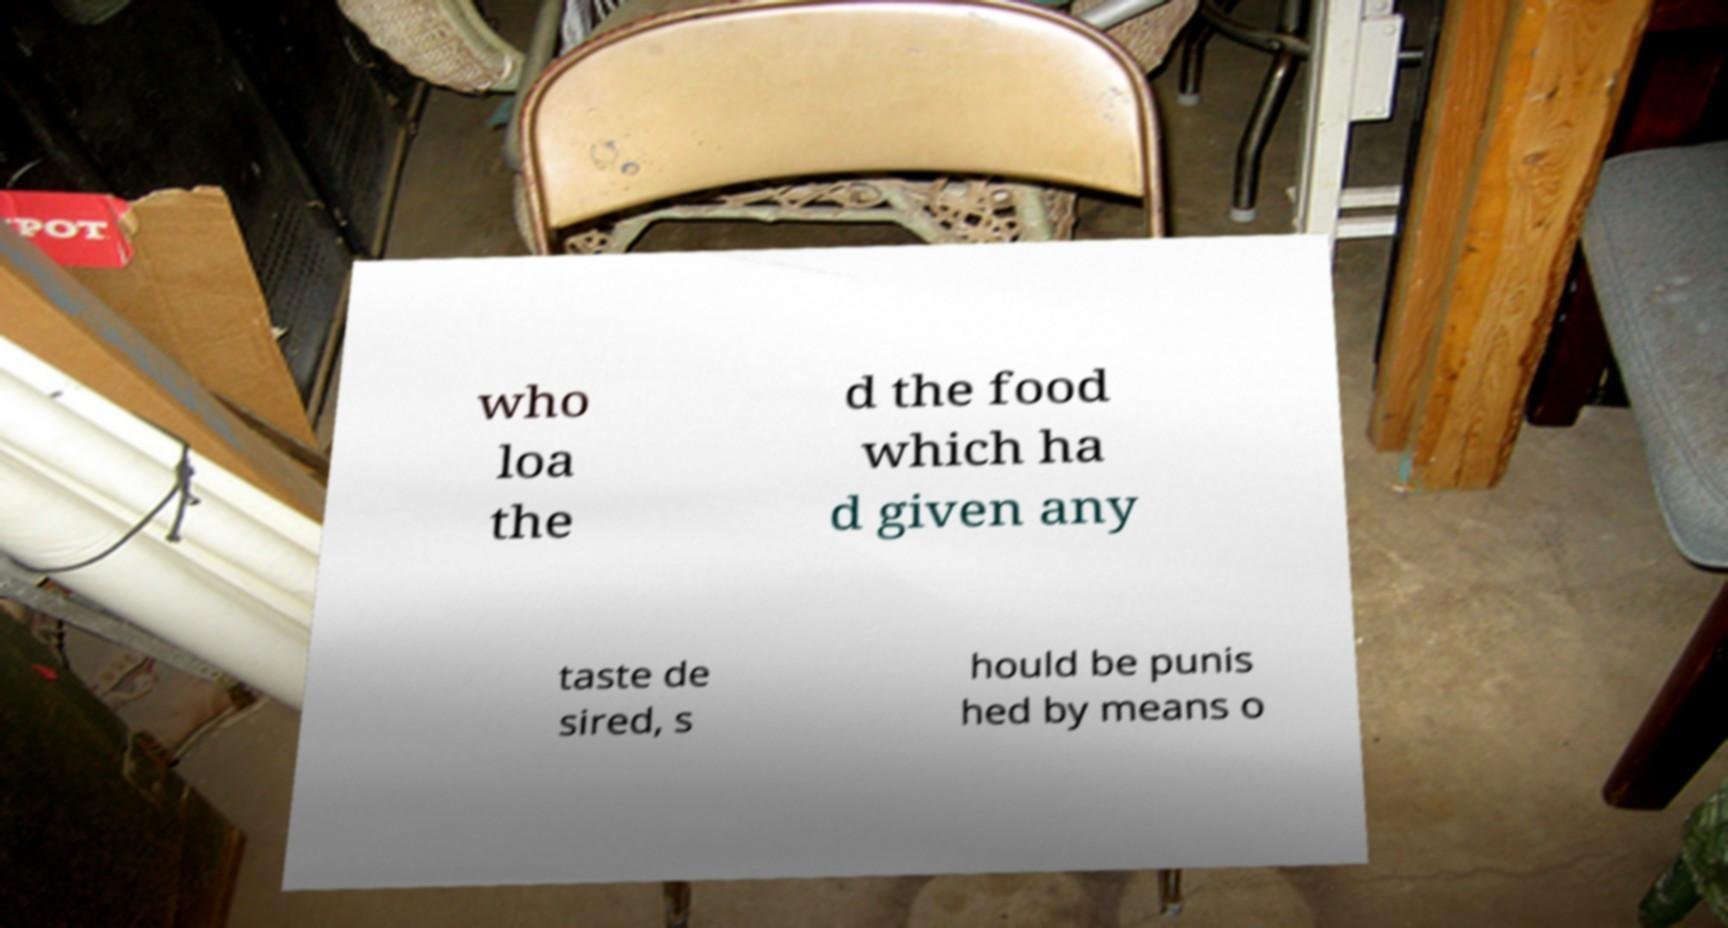Can you accurately transcribe the text from the provided image for me? who loa the d the food which ha d given any taste de sired, s hould be punis hed by means o 